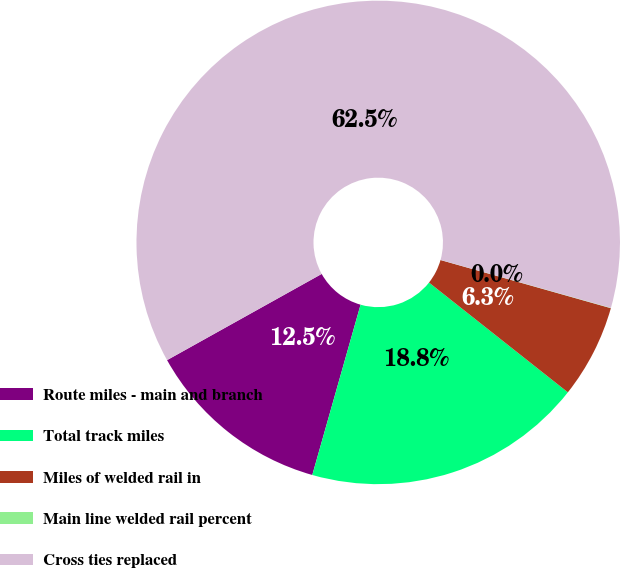Convert chart. <chart><loc_0><loc_0><loc_500><loc_500><pie_chart><fcel>Route miles - main and branch<fcel>Total track miles<fcel>Miles of welded rail in<fcel>Main line welded rail percent<fcel>Cross ties replaced<nl><fcel>12.51%<fcel>18.75%<fcel>6.26%<fcel>0.02%<fcel>62.46%<nl></chart> 